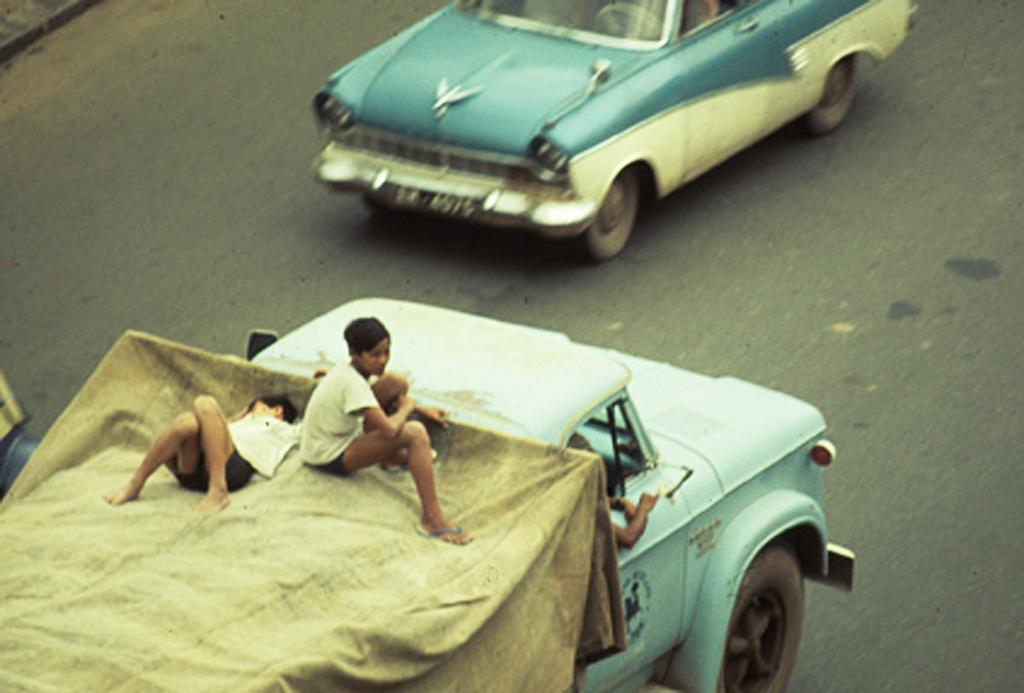How would you summarize this image in a sentence or two? In the image there are two vehicles moving on the road in the opposite direction and on the second vehicle there are two kids residing on a cloth the first one is sleeping and the second kid is sitting. 